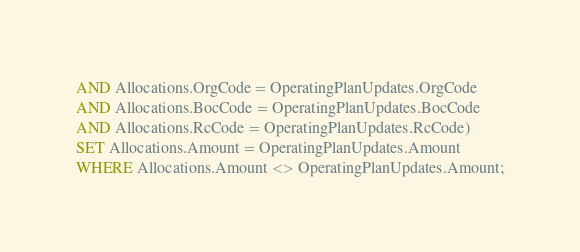Convert code to text. <code><loc_0><loc_0><loc_500><loc_500><_SQL_>AND Allocations.OrgCode = OperatingPlanUpdates.OrgCode 
AND Allocations.BocCode = OperatingPlanUpdates.BocCode 
AND Allocations.RcCode = OperatingPlanUpdates.RcCode) 
SET Allocations.Amount = OperatingPlanUpdates.Amount
WHERE Allocations.Amount <> OperatingPlanUpdates.Amount;</code> 